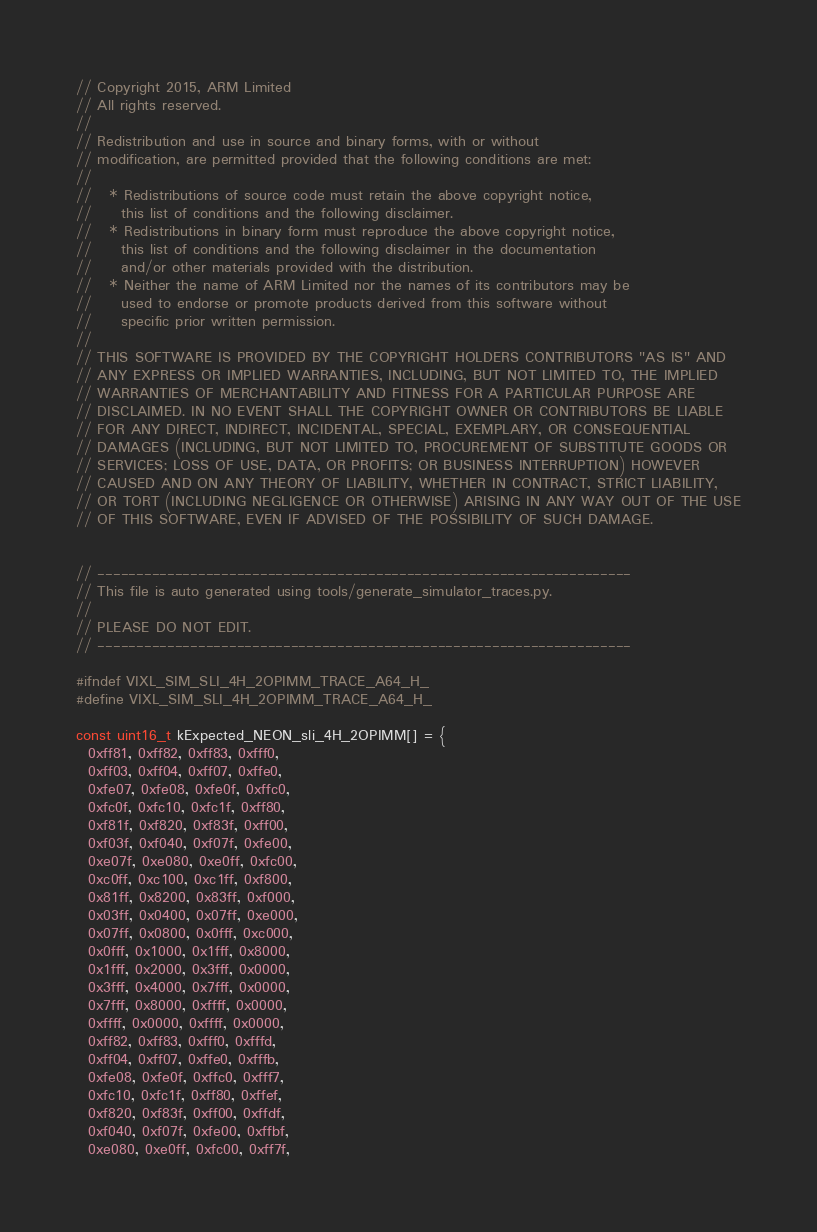<code> <loc_0><loc_0><loc_500><loc_500><_C_>// Copyright 2015, ARM Limited
// All rights reserved.
//
// Redistribution and use in source and binary forms, with or without
// modification, are permitted provided that the following conditions are met:
//
//   * Redistributions of source code must retain the above copyright notice,
//     this list of conditions and the following disclaimer.
//   * Redistributions in binary form must reproduce the above copyright notice,
//     this list of conditions and the following disclaimer in the documentation
//     and/or other materials provided with the distribution.
//   * Neither the name of ARM Limited nor the names of its contributors may be
//     used to endorse or promote products derived from this software without
//     specific prior written permission.
//
// THIS SOFTWARE IS PROVIDED BY THE COPYRIGHT HOLDERS CONTRIBUTORS "AS IS" AND
// ANY EXPRESS OR IMPLIED WARRANTIES, INCLUDING, BUT NOT LIMITED TO, THE IMPLIED
// WARRANTIES OF MERCHANTABILITY AND FITNESS FOR A PARTICULAR PURPOSE ARE
// DISCLAIMED. IN NO EVENT SHALL THE COPYRIGHT OWNER OR CONTRIBUTORS BE LIABLE
// FOR ANY DIRECT, INDIRECT, INCIDENTAL, SPECIAL, EXEMPLARY, OR CONSEQUENTIAL
// DAMAGES (INCLUDING, BUT NOT LIMITED TO, PROCUREMENT OF SUBSTITUTE GOODS OR
// SERVICES; LOSS OF USE, DATA, OR PROFITS; OR BUSINESS INTERRUPTION) HOWEVER
// CAUSED AND ON ANY THEORY OF LIABILITY, WHETHER IN CONTRACT, STRICT LIABILITY,
// OR TORT (INCLUDING NEGLIGENCE OR OTHERWISE) ARISING IN ANY WAY OUT OF THE USE
// OF THIS SOFTWARE, EVEN IF ADVISED OF THE POSSIBILITY OF SUCH DAMAGE.


// ---------------------------------------------------------------------
// This file is auto generated using tools/generate_simulator_traces.py.
//
// PLEASE DO NOT EDIT.
// ---------------------------------------------------------------------

#ifndef VIXL_SIM_SLI_4H_2OPIMM_TRACE_A64_H_
#define VIXL_SIM_SLI_4H_2OPIMM_TRACE_A64_H_

const uint16_t kExpected_NEON_sli_4H_2OPIMM[] = {
  0xff81, 0xff82, 0xff83, 0xfff0,
  0xff03, 0xff04, 0xff07, 0xffe0,
  0xfe07, 0xfe08, 0xfe0f, 0xffc0,
  0xfc0f, 0xfc10, 0xfc1f, 0xff80,
  0xf81f, 0xf820, 0xf83f, 0xff00,
  0xf03f, 0xf040, 0xf07f, 0xfe00,
  0xe07f, 0xe080, 0xe0ff, 0xfc00,
  0xc0ff, 0xc100, 0xc1ff, 0xf800,
  0x81ff, 0x8200, 0x83ff, 0xf000,
  0x03ff, 0x0400, 0x07ff, 0xe000,
  0x07ff, 0x0800, 0x0fff, 0xc000,
  0x0fff, 0x1000, 0x1fff, 0x8000,
  0x1fff, 0x2000, 0x3fff, 0x0000,
  0x3fff, 0x4000, 0x7fff, 0x0000,
  0x7fff, 0x8000, 0xffff, 0x0000,
  0xffff, 0x0000, 0xffff, 0x0000,
  0xff82, 0xff83, 0xfff0, 0xfffd,
  0xff04, 0xff07, 0xffe0, 0xfffb,
  0xfe08, 0xfe0f, 0xffc0, 0xfff7,
  0xfc10, 0xfc1f, 0xff80, 0xffef,
  0xf820, 0xf83f, 0xff00, 0xffdf,
  0xf040, 0xf07f, 0xfe00, 0xffbf,
  0xe080, 0xe0ff, 0xfc00, 0xff7f,</code> 